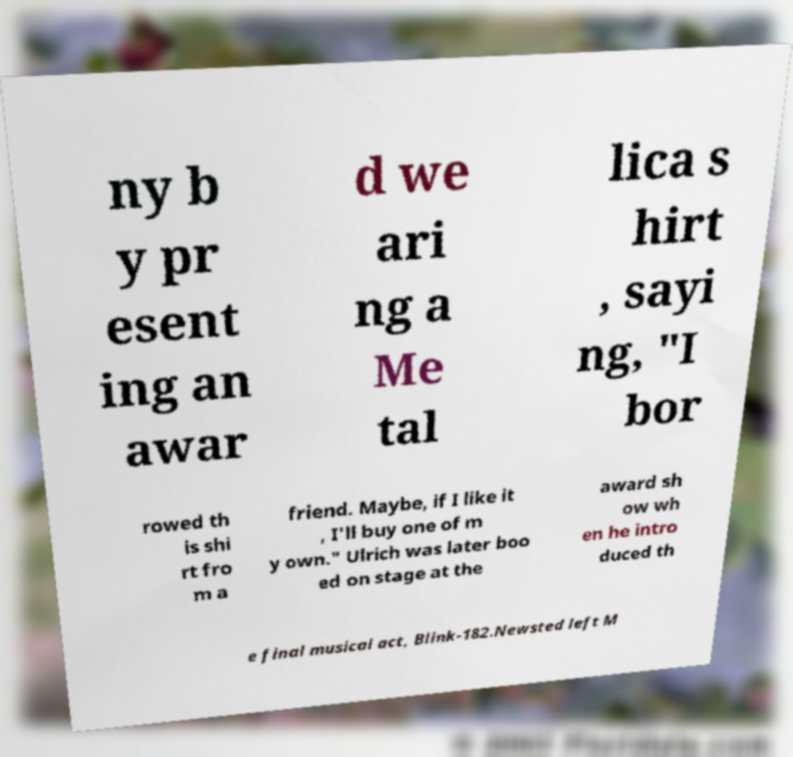Can you accurately transcribe the text from the provided image for me? ny b y pr esent ing an awar d we ari ng a Me tal lica s hirt , sayi ng, "I bor rowed th is shi rt fro m a friend. Maybe, if I like it , I'll buy one of m y own." Ulrich was later boo ed on stage at the award sh ow wh en he intro duced th e final musical act, Blink-182.Newsted left M 